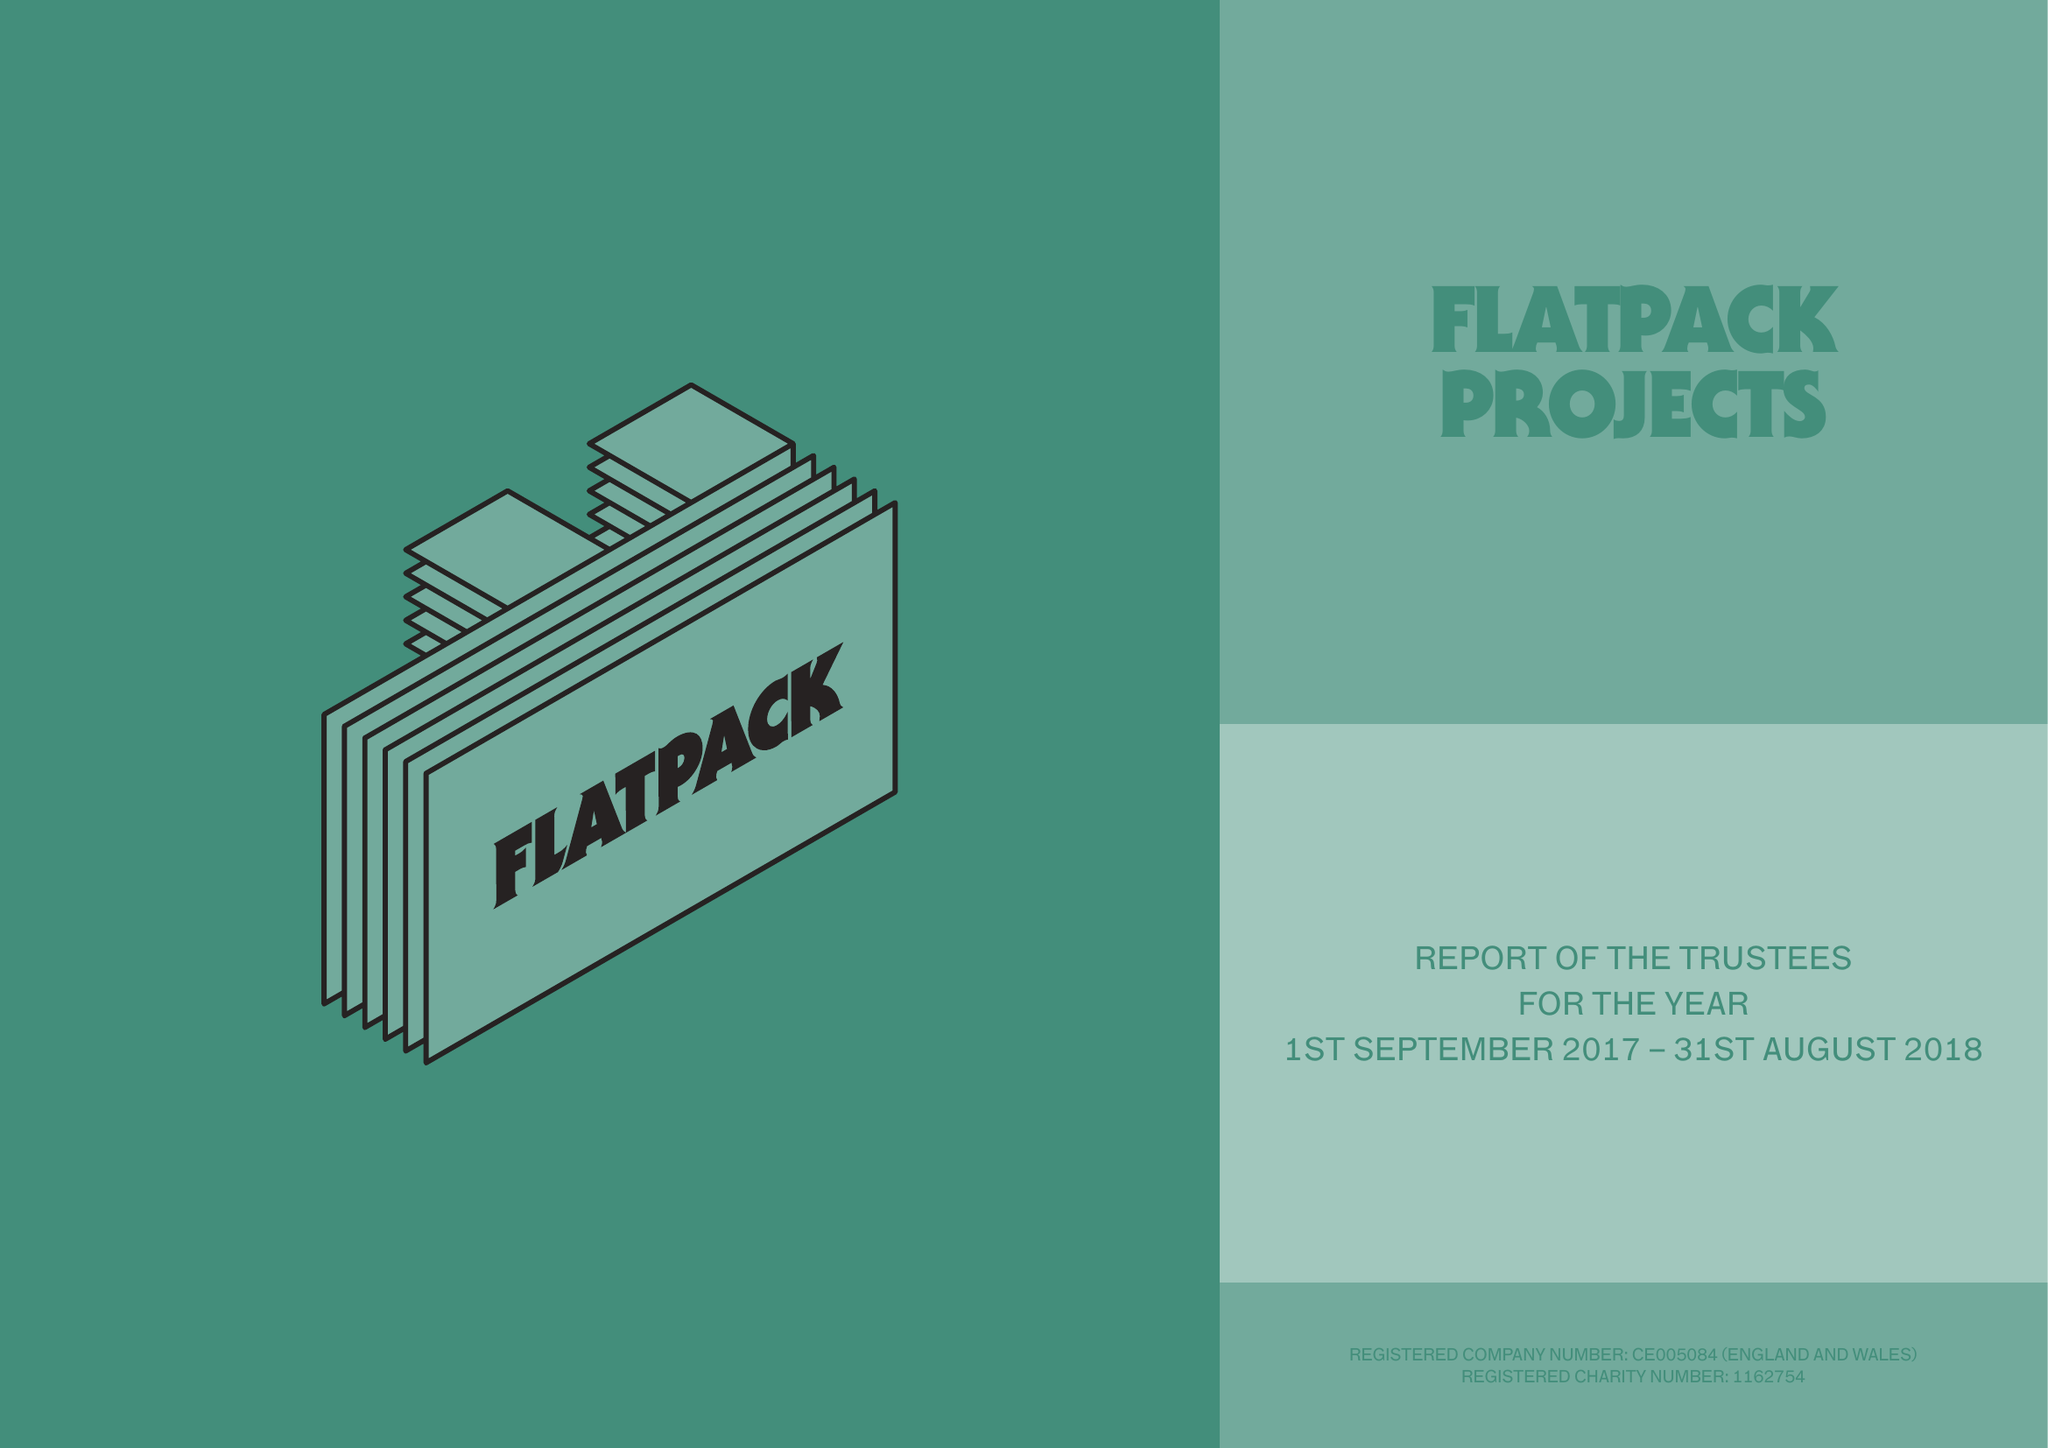What is the value for the address__postcode?
Answer the question using a single word or phrase. B9 4AA 